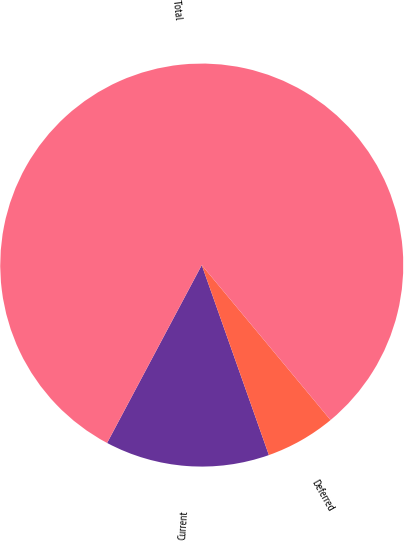Convert chart. <chart><loc_0><loc_0><loc_500><loc_500><pie_chart><fcel>Current<fcel>Deferred<fcel>Total<nl><fcel>13.19%<fcel>5.63%<fcel>81.18%<nl></chart> 